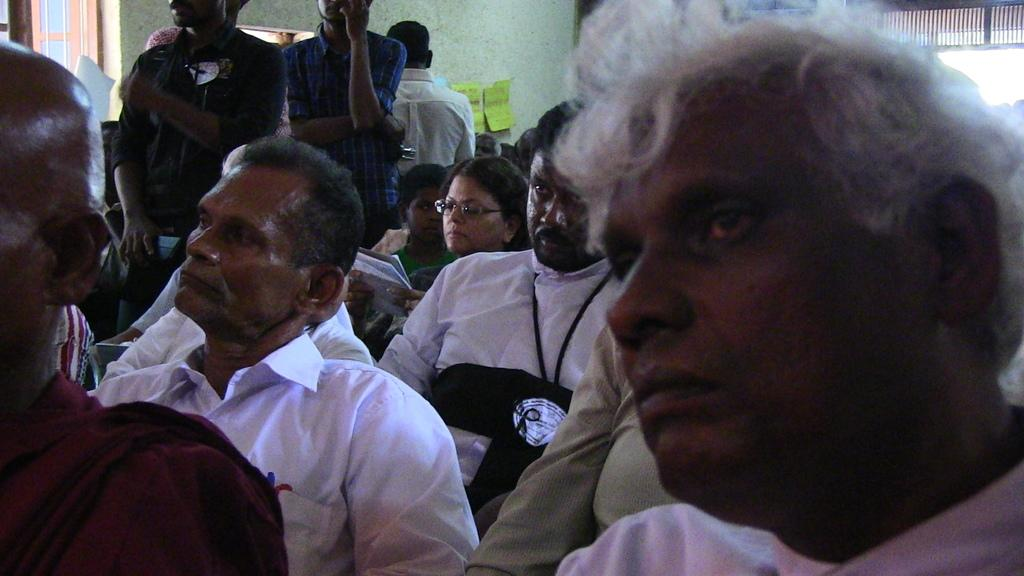What are the people in the image doing? There are people sitting and standing in the image. What can be seen in the background of the image? There is a window and papers attached to the wall visible in the background of the image. What is the condition of the car in the image? There is no car present in the image. What type of base is supporting the people in the image? The people are standing or sitting on a floor or ground, which is not specifically referred to as a "base" in the image. 